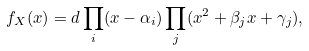<formula> <loc_0><loc_0><loc_500><loc_500>f _ { X } ( x ) & = d \prod _ { i } ( x - \alpha _ { i } ) \prod _ { j } ( x ^ { 2 } + \beta _ { j } x + \gamma _ { j } ) ,</formula> 